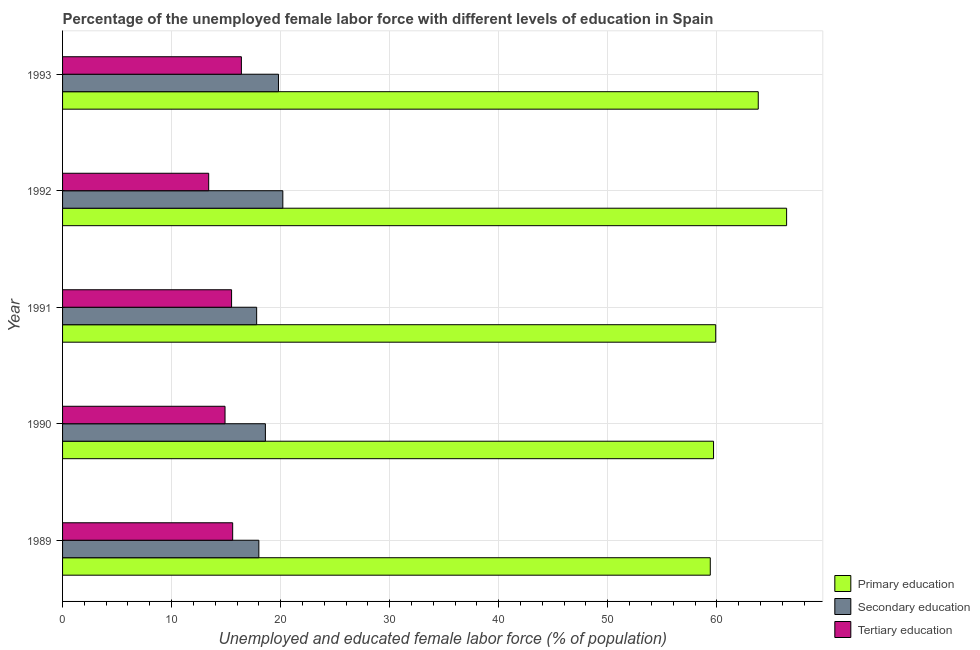Are the number of bars per tick equal to the number of legend labels?
Give a very brief answer. Yes. How many bars are there on the 2nd tick from the top?
Provide a short and direct response. 3. What is the label of the 1st group of bars from the top?
Your answer should be compact. 1993. What is the percentage of female labor force who received secondary education in 1989?
Provide a succinct answer. 18. Across all years, what is the maximum percentage of female labor force who received tertiary education?
Your answer should be very brief. 16.4. Across all years, what is the minimum percentage of female labor force who received tertiary education?
Your answer should be compact. 13.4. What is the total percentage of female labor force who received secondary education in the graph?
Offer a very short reply. 94.4. What is the difference between the percentage of female labor force who received secondary education in 1991 and that in 1992?
Your answer should be very brief. -2.4. What is the difference between the percentage of female labor force who received secondary education in 1991 and the percentage of female labor force who received tertiary education in 1990?
Your response must be concise. 2.9. What is the average percentage of female labor force who received primary education per year?
Provide a short and direct response. 61.84. In the year 1992, what is the difference between the percentage of female labor force who received tertiary education and percentage of female labor force who received primary education?
Offer a terse response. -53. In how many years, is the percentage of female labor force who received secondary education greater than 50 %?
Your response must be concise. 0. What is the ratio of the percentage of female labor force who received secondary education in 1991 to that in 1993?
Ensure brevity in your answer.  0.9. What is the difference between the highest and the second highest percentage of female labor force who received secondary education?
Make the answer very short. 0.4. What does the 1st bar from the top in 1992 represents?
Provide a succinct answer. Tertiary education. Does the graph contain grids?
Your answer should be very brief. Yes. How many legend labels are there?
Your response must be concise. 3. How are the legend labels stacked?
Your answer should be very brief. Vertical. What is the title of the graph?
Offer a terse response. Percentage of the unemployed female labor force with different levels of education in Spain. What is the label or title of the X-axis?
Offer a terse response. Unemployed and educated female labor force (% of population). What is the Unemployed and educated female labor force (% of population) of Primary education in 1989?
Your answer should be very brief. 59.4. What is the Unemployed and educated female labor force (% of population) in Tertiary education in 1989?
Offer a terse response. 15.6. What is the Unemployed and educated female labor force (% of population) of Primary education in 1990?
Keep it short and to the point. 59.7. What is the Unemployed and educated female labor force (% of population) in Secondary education in 1990?
Your answer should be compact. 18.6. What is the Unemployed and educated female labor force (% of population) of Tertiary education in 1990?
Offer a very short reply. 14.9. What is the Unemployed and educated female labor force (% of population) of Primary education in 1991?
Your answer should be very brief. 59.9. What is the Unemployed and educated female labor force (% of population) of Secondary education in 1991?
Your answer should be very brief. 17.8. What is the Unemployed and educated female labor force (% of population) of Tertiary education in 1991?
Give a very brief answer. 15.5. What is the Unemployed and educated female labor force (% of population) in Primary education in 1992?
Ensure brevity in your answer.  66.4. What is the Unemployed and educated female labor force (% of population) of Secondary education in 1992?
Provide a short and direct response. 20.2. What is the Unemployed and educated female labor force (% of population) of Tertiary education in 1992?
Keep it short and to the point. 13.4. What is the Unemployed and educated female labor force (% of population) of Primary education in 1993?
Offer a very short reply. 63.8. What is the Unemployed and educated female labor force (% of population) of Secondary education in 1993?
Make the answer very short. 19.8. What is the Unemployed and educated female labor force (% of population) of Tertiary education in 1993?
Provide a short and direct response. 16.4. Across all years, what is the maximum Unemployed and educated female labor force (% of population) in Primary education?
Your answer should be compact. 66.4. Across all years, what is the maximum Unemployed and educated female labor force (% of population) of Secondary education?
Make the answer very short. 20.2. Across all years, what is the maximum Unemployed and educated female labor force (% of population) in Tertiary education?
Offer a terse response. 16.4. Across all years, what is the minimum Unemployed and educated female labor force (% of population) in Primary education?
Keep it short and to the point. 59.4. Across all years, what is the minimum Unemployed and educated female labor force (% of population) of Secondary education?
Offer a terse response. 17.8. Across all years, what is the minimum Unemployed and educated female labor force (% of population) in Tertiary education?
Make the answer very short. 13.4. What is the total Unemployed and educated female labor force (% of population) of Primary education in the graph?
Your response must be concise. 309.2. What is the total Unemployed and educated female labor force (% of population) of Secondary education in the graph?
Your answer should be very brief. 94.4. What is the total Unemployed and educated female labor force (% of population) in Tertiary education in the graph?
Ensure brevity in your answer.  75.8. What is the difference between the Unemployed and educated female labor force (% of population) in Primary education in 1989 and that in 1990?
Your response must be concise. -0.3. What is the difference between the Unemployed and educated female labor force (% of population) of Tertiary education in 1989 and that in 1992?
Make the answer very short. 2.2. What is the difference between the Unemployed and educated female labor force (% of population) of Secondary education in 1990 and that in 1991?
Your response must be concise. 0.8. What is the difference between the Unemployed and educated female labor force (% of population) in Tertiary education in 1990 and that in 1991?
Make the answer very short. -0.6. What is the difference between the Unemployed and educated female labor force (% of population) in Tertiary education in 1990 and that in 1992?
Provide a short and direct response. 1.5. What is the difference between the Unemployed and educated female labor force (% of population) of Secondary education in 1990 and that in 1993?
Offer a terse response. -1.2. What is the difference between the Unemployed and educated female labor force (% of population) of Tertiary education in 1990 and that in 1993?
Ensure brevity in your answer.  -1.5. What is the difference between the Unemployed and educated female labor force (% of population) in Primary education in 1991 and that in 1992?
Offer a terse response. -6.5. What is the difference between the Unemployed and educated female labor force (% of population) of Secondary education in 1991 and that in 1992?
Offer a very short reply. -2.4. What is the difference between the Unemployed and educated female labor force (% of population) in Tertiary education in 1991 and that in 1993?
Your answer should be very brief. -0.9. What is the difference between the Unemployed and educated female labor force (% of population) of Primary education in 1992 and that in 1993?
Your answer should be very brief. 2.6. What is the difference between the Unemployed and educated female labor force (% of population) of Tertiary education in 1992 and that in 1993?
Your answer should be very brief. -3. What is the difference between the Unemployed and educated female labor force (% of population) of Primary education in 1989 and the Unemployed and educated female labor force (% of population) of Secondary education in 1990?
Offer a very short reply. 40.8. What is the difference between the Unemployed and educated female labor force (% of population) in Primary education in 1989 and the Unemployed and educated female labor force (% of population) in Tertiary education in 1990?
Offer a very short reply. 44.5. What is the difference between the Unemployed and educated female labor force (% of population) in Secondary education in 1989 and the Unemployed and educated female labor force (% of population) in Tertiary education in 1990?
Your answer should be compact. 3.1. What is the difference between the Unemployed and educated female labor force (% of population) in Primary education in 1989 and the Unemployed and educated female labor force (% of population) in Secondary education in 1991?
Make the answer very short. 41.6. What is the difference between the Unemployed and educated female labor force (% of population) in Primary education in 1989 and the Unemployed and educated female labor force (% of population) in Tertiary education in 1991?
Your response must be concise. 43.9. What is the difference between the Unemployed and educated female labor force (% of population) in Secondary education in 1989 and the Unemployed and educated female labor force (% of population) in Tertiary education in 1991?
Your response must be concise. 2.5. What is the difference between the Unemployed and educated female labor force (% of population) in Primary education in 1989 and the Unemployed and educated female labor force (% of population) in Secondary education in 1992?
Keep it short and to the point. 39.2. What is the difference between the Unemployed and educated female labor force (% of population) in Primary education in 1989 and the Unemployed and educated female labor force (% of population) in Secondary education in 1993?
Make the answer very short. 39.6. What is the difference between the Unemployed and educated female labor force (% of population) of Primary education in 1989 and the Unemployed and educated female labor force (% of population) of Tertiary education in 1993?
Make the answer very short. 43. What is the difference between the Unemployed and educated female labor force (% of population) in Primary education in 1990 and the Unemployed and educated female labor force (% of population) in Secondary education in 1991?
Your answer should be compact. 41.9. What is the difference between the Unemployed and educated female labor force (% of population) in Primary education in 1990 and the Unemployed and educated female labor force (% of population) in Tertiary education in 1991?
Your response must be concise. 44.2. What is the difference between the Unemployed and educated female labor force (% of population) in Primary education in 1990 and the Unemployed and educated female labor force (% of population) in Secondary education in 1992?
Make the answer very short. 39.5. What is the difference between the Unemployed and educated female labor force (% of population) of Primary education in 1990 and the Unemployed and educated female labor force (% of population) of Tertiary education in 1992?
Provide a succinct answer. 46.3. What is the difference between the Unemployed and educated female labor force (% of population) in Secondary education in 1990 and the Unemployed and educated female labor force (% of population) in Tertiary education in 1992?
Provide a succinct answer. 5.2. What is the difference between the Unemployed and educated female labor force (% of population) of Primary education in 1990 and the Unemployed and educated female labor force (% of population) of Secondary education in 1993?
Provide a short and direct response. 39.9. What is the difference between the Unemployed and educated female labor force (% of population) of Primary education in 1990 and the Unemployed and educated female labor force (% of population) of Tertiary education in 1993?
Your answer should be very brief. 43.3. What is the difference between the Unemployed and educated female labor force (% of population) in Secondary education in 1990 and the Unemployed and educated female labor force (% of population) in Tertiary education in 1993?
Offer a terse response. 2.2. What is the difference between the Unemployed and educated female labor force (% of population) in Primary education in 1991 and the Unemployed and educated female labor force (% of population) in Secondary education in 1992?
Offer a terse response. 39.7. What is the difference between the Unemployed and educated female labor force (% of population) in Primary education in 1991 and the Unemployed and educated female labor force (% of population) in Tertiary education in 1992?
Make the answer very short. 46.5. What is the difference between the Unemployed and educated female labor force (% of population) in Primary education in 1991 and the Unemployed and educated female labor force (% of population) in Secondary education in 1993?
Keep it short and to the point. 40.1. What is the difference between the Unemployed and educated female labor force (% of population) of Primary education in 1991 and the Unemployed and educated female labor force (% of population) of Tertiary education in 1993?
Ensure brevity in your answer.  43.5. What is the difference between the Unemployed and educated female labor force (% of population) in Secondary education in 1991 and the Unemployed and educated female labor force (% of population) in Tertiary education in 1993?
Offer a very short reply. 1.4. What is the difference between the Unemployed and educated female labor force (% of population) in Primary education in 1992 and the Unemployed and educated female labor force (% of population) in Secondary education in 1993?
Your answer should be compact. 46.6. What is the difference between the Unemployed and educated female labor force (% of population) in Primary education in 1992 and the Unemployed and educated female labor force (% of population) in Tertiary education in 1993?
Provide a succinct answer. 50. What is the difference between the Unemployed and educated female labor force (% of population) of Secondary education in 1992 and the Unemployed and educated female labor force (% of population) of Tertiary education in 1993?
Your answer should be very brief. 3.8. What is the average Unemployed and educated female labor force (% of population) in Primary education per year?
Offer a terse response. 61.84. What is the average Unemployed and educated female labor force (% of population) in Secondary education per year?
Your response must be concise. 18.88. What is the average Unemployed and educated female labor force (% of population) in Tertiary education per year?
Your answer should be very brief. 15.16. In the year 1989, what is the difference between the Unemployed and educated female labor force (% of population) in Primary education and Unemployed and educated female labor force (% of population) in Secondary education?
Ensure brevity in your answer.  41.4. In the year 1989, what is the difference between the Unemployed and educated female labor force (% of population) in Primary education and Unemployed and educated female labor force (% of population) in Tertiary education?
Your answer should be compact. 43.8. In the year 1990, what is the difference between the Unemployed and educated female labor force (% of population) of Primary education and Unemployed and educated female labor force (% of population) of Secondary education?
Offer a very short reply. 41.1. In the year 1990, what is the difference between the Unemployed and educated female labor force (% of population) of Primary education and Unemployed and educated female labor force (% of population) of Tertiary education?
Your response must be concise. 44.8. In the year 1990, what is the difference between the Unemployed and educated female labor force (% of population) of Secondary education and Unemployed and educated female labor force (% of population) of Tertiary education?
Provide a succinct answer. 3.7. In the year 1991, what is the difference between the Unemployed and educated female labor force (% of population) in Primary education and Unemployed and educated female labor force (% of population) in Secondary education?
Offer a very short reply. 42.1. In the year 1991, what is the difference between the Unemployed and educated female labor force (% of population) in Primary education and Unemployed and educated female labor force (% of population) in Tertiary education?
Provide a succinct answer. 44.4. In the year 1992, what is the difference between the Unemployed and educated female labor force (% of population) of Primary education and Unemployed and educated female labor force (% of population) of Secondary education?
Provide a succinct answer. 46.2. In the year 1992, what is the difference between the Unemployed and educated female labor force (% of population) of Primary education and Unemployed and educated female labor force (% of population) of Tertiary education?
Make the answer very short. 53. In the year 1993, what is the difference between the Unemployed and educated female labor force (% of population) in Primary education and Unemployed and educated female labor force (% of population) in Secondary education?
Keep it short and to the point. 44. In the year 1993, what is the difference between the Unemployed and educated female labor force (% of population) in Primary education and Unemployed and educated female labor force (% of population) in Tertiary education?
Make the answer very short. 47.4. In the year 1993, what is the difference between the Unemployed and educated female labor force (% of population) of Secondary education and Unemployed and educated female labor force (% of population) of Tertiary education?
Make the answer very short. 3.4. What is the ratio of the Unemployed and educated female labor force (% of population) in Secondary education in 1989 to that in 1990?
Your response must be concise. 0.97. What is the ratio of the Unemployed and educated female labor force (% of population) of Tertiary education in 1989 to that in 1990?
Offer a terse response. 1.05. What is the ratio of the Unemployed and educated female labor force (% of population) of Secondary education in 1989 to that in 1991?
Your response must be concise. 1.01. What is the ratio of the Unemployed and educated female labor force (% of population) in Primary education in 1989 to that in 1992?
Your answer should be very brief. 0.89. What is the ratio of the Unemployed and educated female labor force (% of population) in Secondary education in 1989 to that in 1992?
Keep it short and to the point. 0.89. What is the ratio of the Unemployed and educated female labor force (% of population) of Tertiary education in 1989 to that in 1992?
Your answer should be compact. 1.16. What is the ratio of the Unemployed and educated female labor force (% of population) in Secondary education in 1989 to that in 1993?
Your answer should be compact. 0.91. What is the ratio of the Unemployed and educated female labor force (% of population) in Tertiary education in 1989 to that in 1993?
Make the answer very short. 0.95. What is the ratio of the Unemployed and educated female labor force (% of population) in Secondary education in 1990 to that in 1991?
Provide a succinct answer. 1.04. What is the ratio of the Unemployed and educated female labor force (% of population) of Tertiary education in 1990 to that in 1991?
Your answer should be very brief. 0.96. What is the ratio of the Unemployed and educated female labor force (% of population) in Primary education in 1990 to that in 1992?
Offer a very short reply. 0.9. What is the ratio of the Unemployed and educated female labor force (% of population) of Secondary education in 1990 to that in 1992?
Your answer should be very brief. 0.92. What is the ratio of the Unemployed and educated female labor force (% of population) of Tertiary education in 1990 to that in 1992?
Your answer should be very brief. 1.11. What is the ratio of the Unemployed and educated female labor force (% of population) of Primary education in 1990 to that in 1993?
Ensure brevity in your answer.  0.94. What is the ratio of the Unemployed and educated female labor force (% of population) of Secondary education in 1990 to that in 1993?
Provide a succinct answer. 0.94. What is the ratio of the Unemployed and educated female labor force (% of population) of Tertiary education in 1990 to that in 1993?
Keep it short and to the point. 0.91. What is the ratio of the Unemployed and educated female labor force (% of population) in Primary education in 1991 to that in 1992?
Provide a succinct answer. 0.9. What is the ratio of the Unemployed and educated female labor force (% of population) of Secondary education in 1991 to that in 1992?
Your response must be concise. 0.88. What is the ratio of the Unemployed and educated female labor force (% of population) of Tertiary education in 1991 to that in 1992?
Keep it short and to the point. 1.16. What is the ratio of the Unemployed and educated female labor force (% of population) of Primary education in 1991 to that in 1993?
Your answer should be very brief. 0.94. What is the ratio of the Unemployed and educated female labor force (% of population) of Secondary education in 1991 to that in 1993?
Offer a very short reply. 0.9. What is the ratio of the Unemployed and educated female labor force (% of population) of Tertiary education in 1991 to that in 1993?
Keep it short and to the point. 0.95. What is the ratio of the Unemployed and educated female labor force (% of population) of Primary education in 1992 to that in 1993?
Your answer should be very brief. 1.04. What is the ratio of the Unemployed and educated female labor force (% of population) in Secondary education in 1992 to that in 1993?
Ensure brevity in your answer.  1.02. What is the ratio of the Unemployed and educated female labor force (% of population) in Tertiary education in 1992 to that in 1993?
Ensure brevity in your answer.  0.82. What is the difference between the highest and the second highest Unemployed and educated female labor force (% of population) of Secondary education?
Provide a short and direct response. 0.4. What is the difference between the highest and the second highest Unemployed and educated female labor force (% of population) in Tertiary education?
Your response must be concise. 0.8. What is the difference between the highest and the lowest Unemployed and educated female labor force (% of population) in Tertiary education?
Provide a short and direct response. 3. 